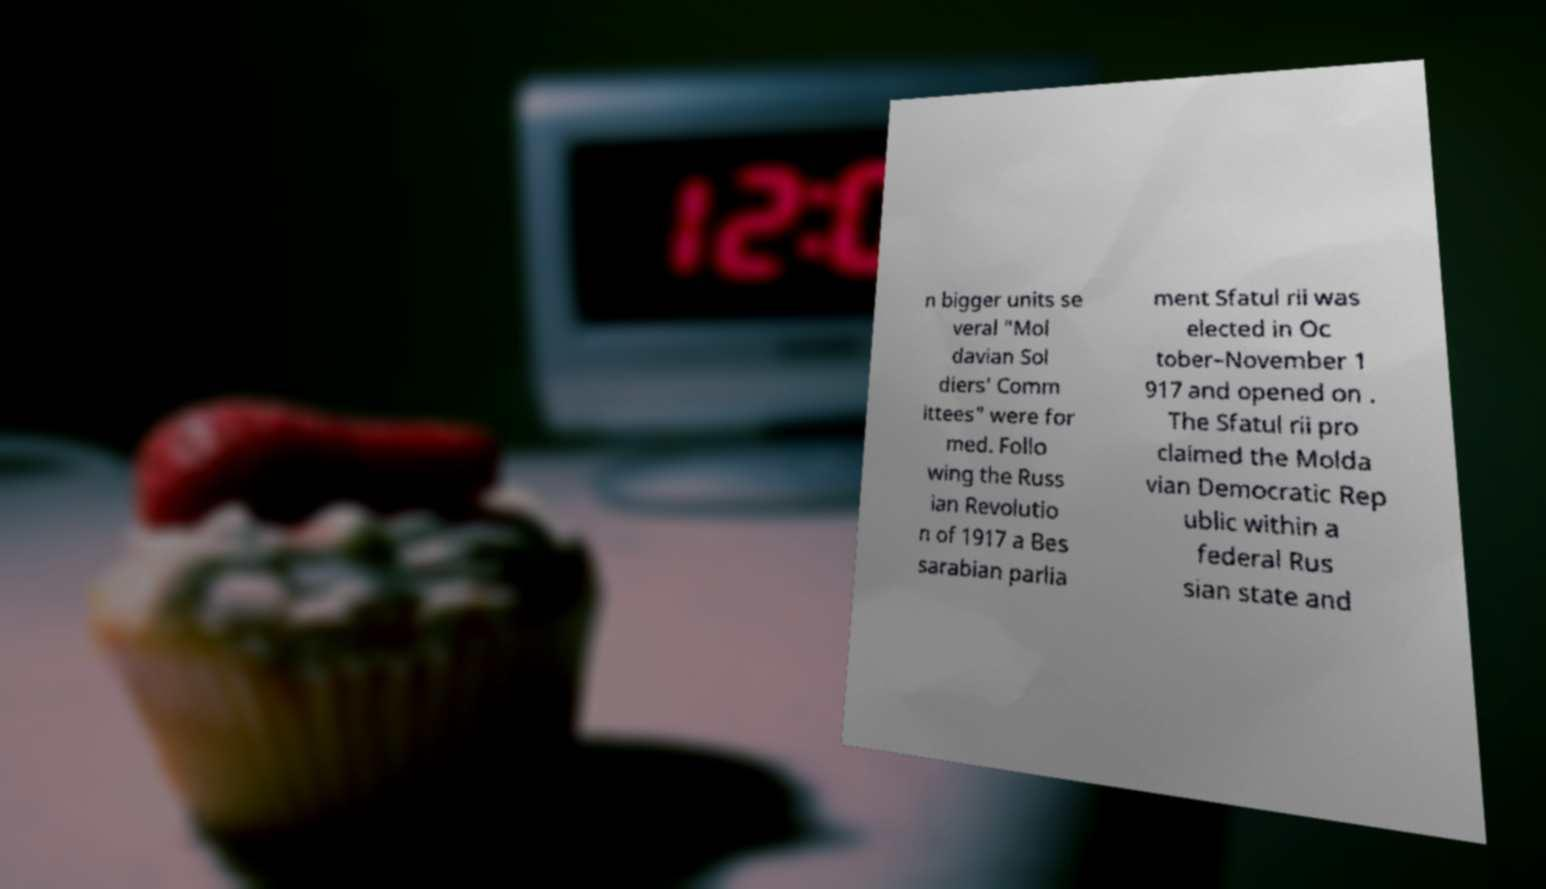Could you extract and type out the text from this image? n bigger units se veral "Mol davian Sol diers' Comm ittees" were for med. Follo wing the Russ ian Revolutio n of 1917 a Bes sarabian parlia ment Sfatul rii was elected in Oc tober–November 1 917 and opened on . The Sfatul rii pro claimed the Molda vian Democratic Rep ublic within a federal Rus sian state and 